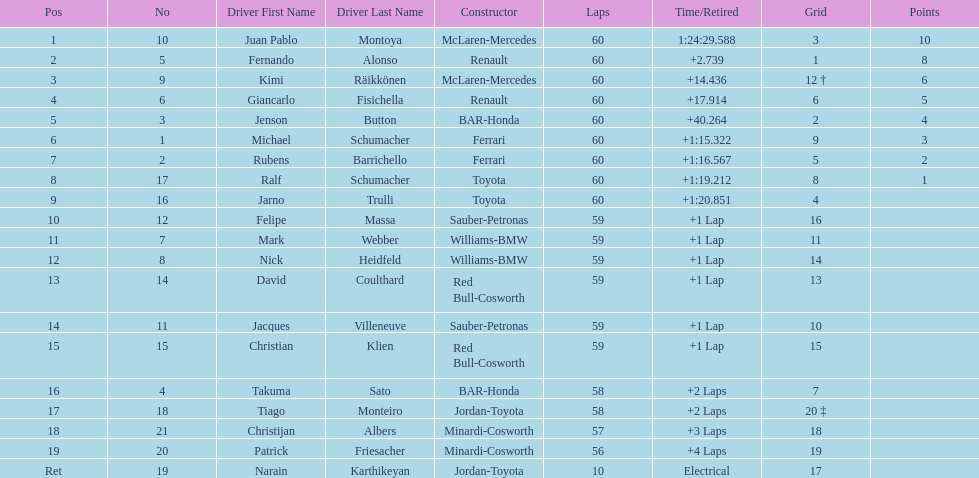How many drivers received points from the race? 8. 